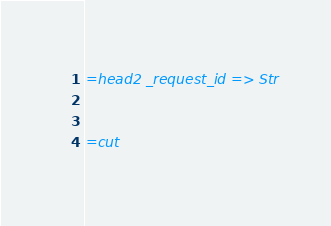Convert code to text. <code><loc_0><loc_0><loc_500><loc_500><_Perl_>

=head2 _request_id => Str


=cut

</code> 